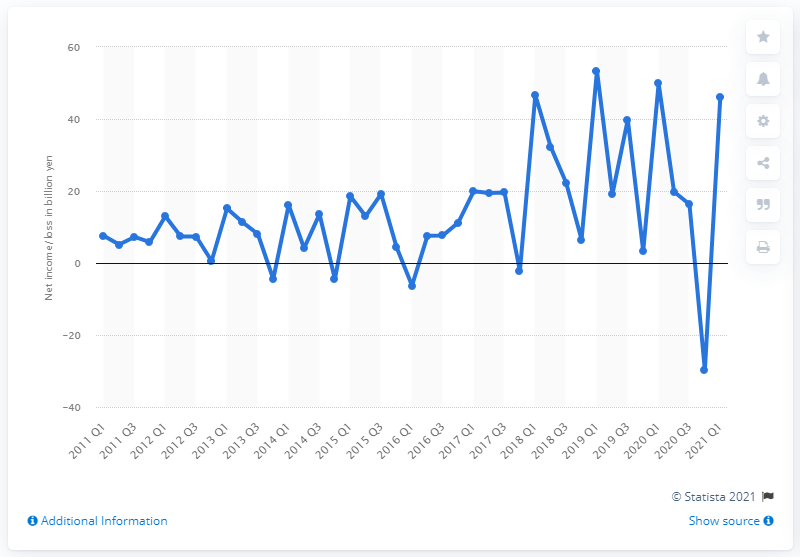Outline some significant characteristics in this image. Nexon's net income in the first quarter of 2021 was 46.03 million. 